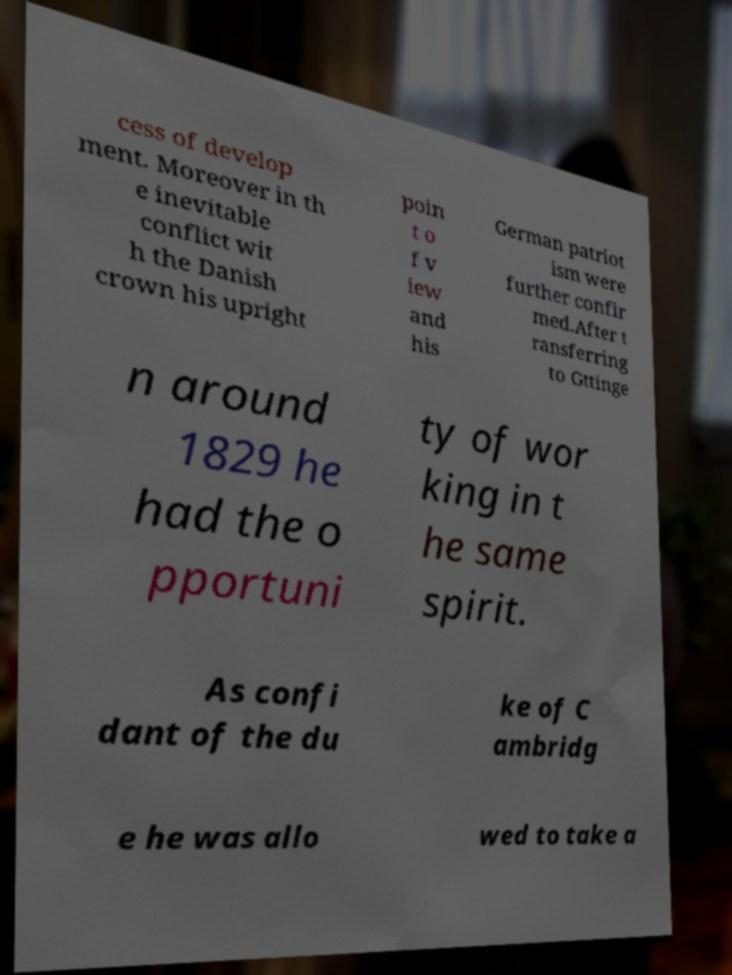Could you extract and type out the text from this image? cess of develop ment. Moreover in th e inevitable conflict wit h the Danish crown his upright poin t o f v iew and his German patriot ism were further confir med.After t ransferring to Gttinge n around 1829 he had the o pportuni ty of wor king in t he same spirit. As confi dant of the du ke of C ambridg e he was allo wed to take a 